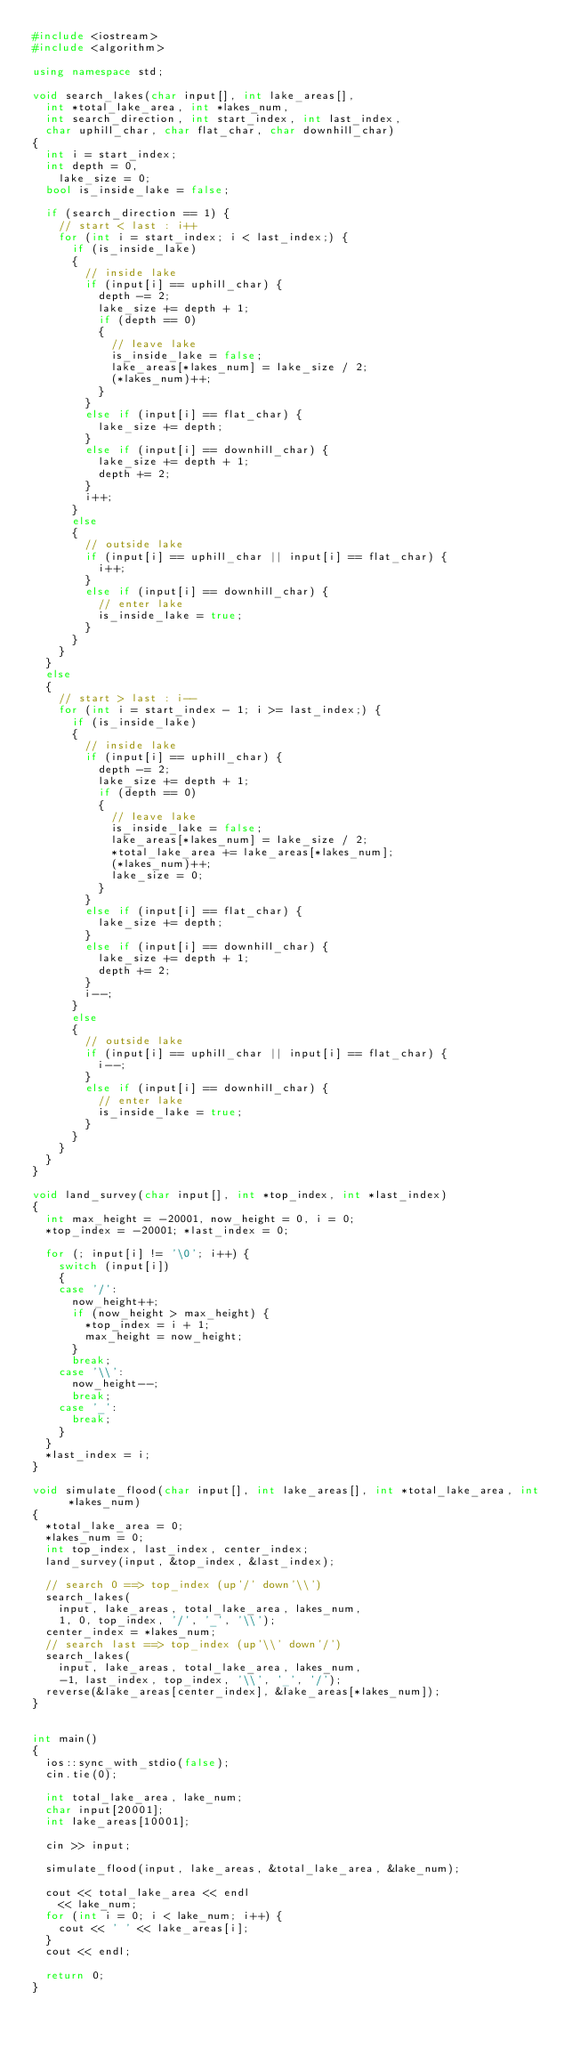<code> <loc_0><loc_0><loc_500><loc_500><_C++_>#include <iostream>
#include <algorithm>

using namespace std;

void search_lakes(char input[], int lake_areas[],
	int *total_lake_area, int *lakes_num,
	int search_direction, int start_index, int last_index,
	char uphill_char, char flat_char, char downhill_char)
{
	int i = start_index;
	int depth = 0,
		lake_size = 0;
	bool is_inside_lake = false;

	if (search_direction == 1) {
		// start < last : i++
		for (int i = start_index; i < last_index;) {
			if (is_inside_lake)
			{
				// inside lake
				if (input[i] == uphill_char) {
					depth -= 2;
					lake_size += depth + 1;
					if (depth == 0)
					{
						// leave lake
						is_inside_lake = false;
						lake_areas[*lakes_num] = lake_size / 2;
						(*lakes_num)++;
					}
				}
				else if (input[i] == flat_char) {
					lake_size += depth;
				}
				else if (input[i] == downhill_char) {
					lake_size += depth + 1;
					depth += 2;
				}
				i++;
			}
			else
			{
				// outside lake
				if (input[i] == uphill_char || input[i] == flat_char) {
					i++;
				}
				else if (input[i] == downhill_char) {
					// enter lake
					is_inside_lake = true;
				}
			}
		}
	}
	else
	{
		// start > last : i--
		for (int i = start_index - 1; i >= last_index;) {
			if (is_inside_lake)
			{
				// inside lake
				if (input[i] == uphill_char) {
					depth -= 2;
					lake_size += depth + 1;
					if (depth == 0)
					{
						// leave lake
						is_inside_lake = false;
						lake_areas[*lakes_num] = lake_size / 2;
						*total_lake_area += lake_areas[*lakes_num];
						(*lakes_num)++;
						lake_size = 0;
					}
				}
				else if (input[i] == flat_char) {
					lake_size += depth;
				}
				else if (input[i] == downhill_char) {
					lake_size += depth + 1;
					depth += 2;
				}
				i--;
			}
			else
			{
				// outside lake
				if (input[i] == uphill_char || input[i] == flat_char) {
					i--;
				}
				else if (input[i] == downhill_char) {
					// enter lake
					is_inside_lake = true;
				}
			}
		}
	}
}

void land_survey(char input[], int *top_index, int *last_index)
{
	int max_height = -20001, now_height = 0, i = 0;
	*top_index = -20001; *last_index = 0;

	for (; input[i] != '\0'; i++) {
		switch (input[i])
		{
		case '/':
			now_height++;
			if (now_height > max_height) {
				*top_index = i + 1;
				max_height = now_height;
			}
			break;
		case '\\':
			now_height--;
			break;
		case '_':
			break;
		}
	}
	*last_index = i;
}

void simulate_flood(char input[], int lake_areas[], int *total_lake_area, int *lakes_num)
{
	*total_lake_area = 0;
	*lakes_num = 0;
	int top_index, last_index, center_index;
	land_survey(input, &top_index, &last_index);

	// search 0 ==> top_index (up'/' down'\\')
	search_lakes(
		input, lake_areas, total_lake_area, lakes_num,
		1, 0, top_index, '/', '_', '\\');
	center_index = *lakes_num;
	// search last ==> top_index (up'\\' down'/')
	search_lakes(
		input, lake_areas, total_lake_area, lakes_num,
		-1, last_index, top_index, '\\', '_', '/');
	reverse(&lake_areas[center_index], &lake_areas[*lakes_num]);
}


int main()
{
	ios::sync_with_stdio(false);
	cin.tie(0);

	int total_lake_area, lake_num;
	char input[20001];
	int lake_areas[10001];

	cin >> input;

	simulate_flood(input, lake_areas, &total_lake_area, &lake_num);

	cout << total_lake_area << endl
		<< lake_num;
	for (int i = 0; i < lake_num; i++) {
		cout << ' ' << lake_areas[i];
	}
	cout << endl;

	return 0;
}</code> 